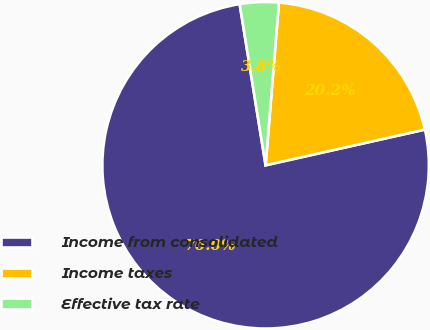<chart> <loc_0><loc_0><loc_500><loc_500><pie_chart><fcel>Income from consolidated<fcel>Income taxes<fcel>Effective tax rate<nl><fcel>75.97%<fcel>20.19%<fcel>3.84%<nl></chart> 